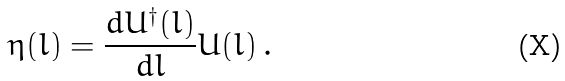Convert formula to latex. <formula><loc_0><loc_0><loc_500><loc_500>\eta ( l ) = \frac { d U ^ { \dagger } ( l ) } { d l } U ( l ) \, .</formula> 